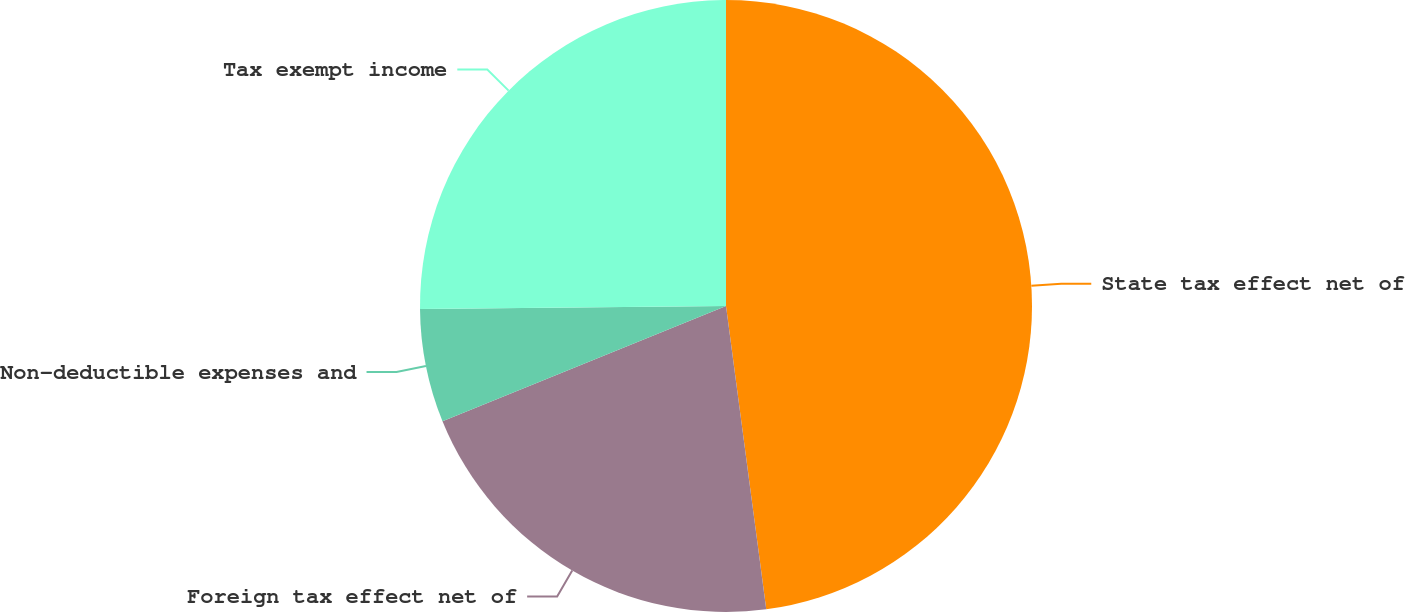Convert chart. <chart><loc_0><loc_0><loc_500><loc_500><pie_chart><fcel>State tax effect net of<fcel>Foreign tax effect net of<fcel>Non-deductible expenses and<fcel>Tax exempt income<nl><fcel>47.9%<fcel>20.96%<fcel>5.99%<fcel>25.15%<nl></chart> 